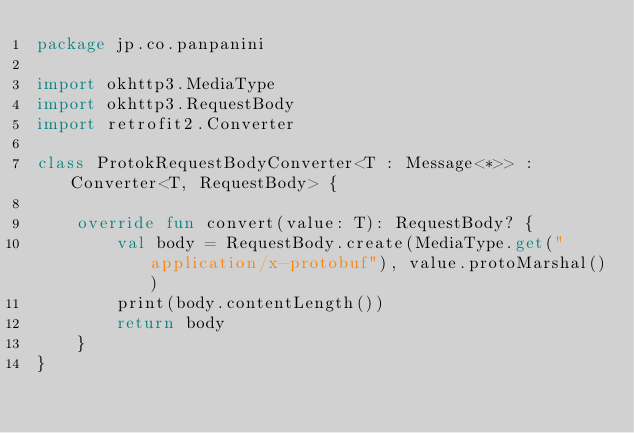<code> <loc_0><loc_0><loc_500><loc_500><_Kotlin_>package jp.co.panpanini

import okhttp3.MediaType
import okhttp3.RequestBody
import retrofit2.Converter

class ProtokRequestBodyConverter<T : Message<*>> : Converter<T, RequestBody> {

    override fun convert(value: T): RequestBody? {
        val body = RequestBody.create(MediaType.get("application/x-protobuf"), value.protoMarshal())
        print(body.contentLength())
        return body
    }
}</code> 